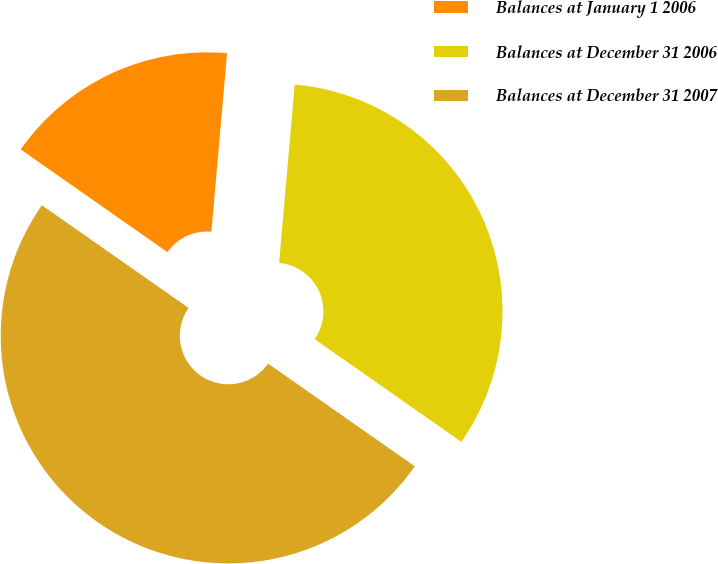Convert chart. <chart><loc_0><loc_0><loc_500><loc_500><pie_chart><fcel>Balances at January 1 2006<fcel>Balances at December 31 2006<fcel>Balances at December 31 2007<nl><fcel>16.67%<fcel>33.33%<fcel>50.0%<nl></chart> 